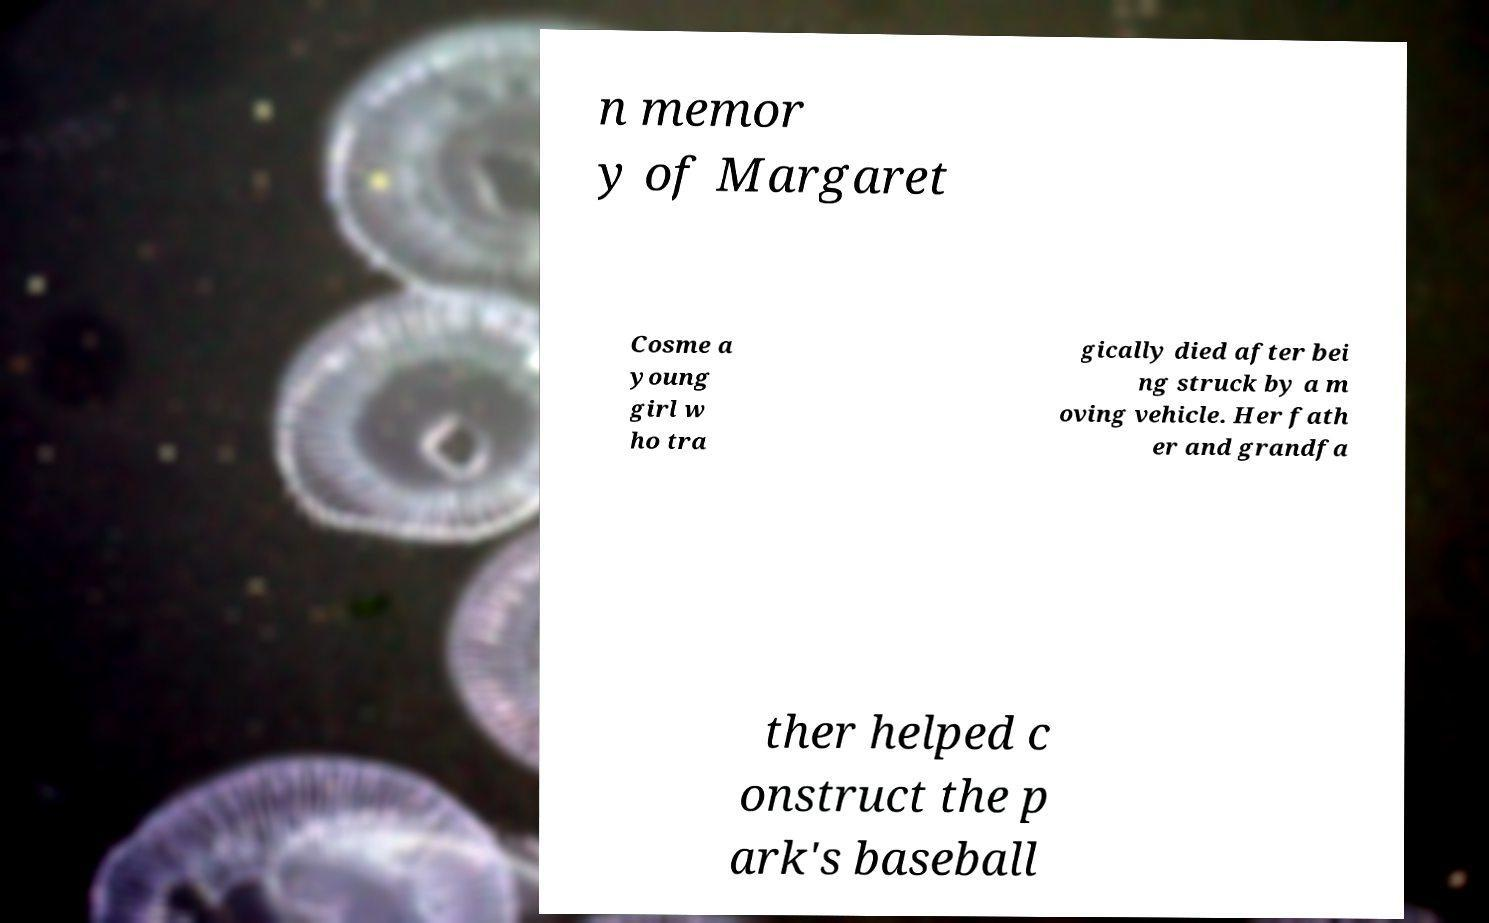Please read and relay the text visible in this image. What does it say? n memor y of Margaret Cosme a young girl w ho tra gically died after bei ng struck by a m oving vehicle. Her fath er and grandfa ther helped c onstruct the p ark's baseball 